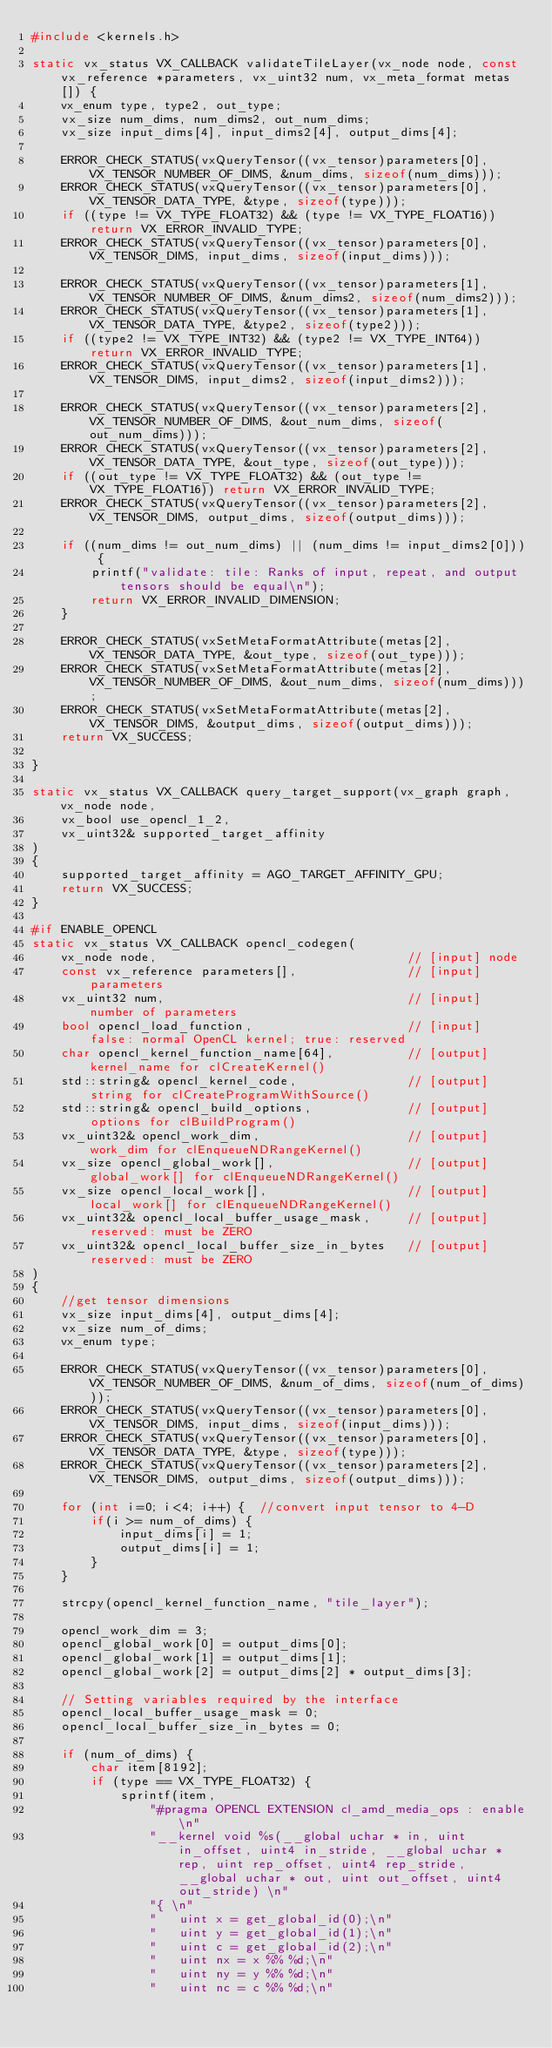Convert code to text. <code><loc_0><loc_0><loc_500><loc_500><_C++_>#include <kernels.h>

static vx_status VX_CALLBACK validateTileLayer(vx_node node, const vx_reference *parameters, vx_uint32 num, vx_meta_format metas[]) {
    vx_enum type, type2, out_type;
    vx_size num_dims, num_dims2, out_num_dims;
    vx_size input_dims[4], input_dims2[4], output_dims[4];
    
    ERROR_CHECK_STATUS(vxQueryTensor((vx_tensor)parameters[0], VX_TENSOR_NUMBER_OF_DIMS, &num_dims, sizeof(num_dims)));
    ERROR_CHECK_STATUS(vxQueryTensor((vx_tensor)parameters[0], VX_TENSOR_DATA_TYPE, &type, sizeof(type)));
    if ((type != VX_TYPE_FLOAT32) && (type != VX_TYPE_FLOAT16)) return VX_ERROR_INVALID_TYPE;
    ERROR_CHECK_STATUS(vxQueryTensor((vx_tensor)parameters[0], VX_TENSOR_DIMS, input_dims, sizeof(input_dims)));

    ERROR_CHECK_STATUS(vxQueryTensor((vx_tensor)parameters[1], VX_TENSOR_NUMBER_OF_DIMS, &num_dims2, sizeof(num_dims2)));
    ERROR_CHECK_STATUS(vxQueryTensor((vx_tensor)parameters[1], VX_TENSOR_DATA_TYPE, &type2, sizeof(type2)));
    if ((type2 != VX_TYPE_INT32) && (type2 != VX_TYPE_INT64)) return VX_ERROR_INVALID_TYPE;
    ERROR_CHECK_STATUS(vxQueryTensor((vx_tensor)parameters[1], VX_TENSOR_DIMS, input_dims2, sizeof(input_dims2)));

    ERROR_CHECK_STATUS(vxQueryTensor((vx_tensor)parameters[2], VX_TENSOR_NUMBER_OF_DIMS, &out_num_dims, sizeof(out_num_dims)));
    ERROR_CHECK_STATUS(vxQueryTensor((vx_tensor)parameters[2], VX_TENSOR_DATA_TYPE, &out_type, sizeof(out_type)));
    if ((out_type != VX_TYPE_FLOAT32) && (out_type != VX_TYPE_FLOAT16)) return VX_ERROR_INVALID_TYPE;
    ERROR_CHECK_STATUS(vxQueryTensor((vx_tensor)parameters[2], VX_TENSOR_DIMS, output_dims, sizeof(output_dims)));

    if ((num_dims != out_num_dims) || (num_dims != input_dims2[0])) {
        printf("validate: tile: Ranks of input, repeat, and output tensors should be equal\n");
        return VX_ERROR_INVALID_DIMENSION;        
    }

    ERROR_CHECK_STATUS(vxSetMetaFormatAttribute(metas[2], VX_TENSOR_DATA_TYPE, &out_type, sizeof(out_type)));
    ERROR_CHECK_STATUS(vxSetMetaFormatAttribute(metas[2], VX_TENSOR_NUMBER_OF_DIMS, &out_num_dims, sizeof(num_dims)));
    ERROR_CHECK_STATUS(vxSetMetaFormatAttribute(metas[2], VX_TENSOR_DIMS, &output_dims, sizeof(output_dims)));
    return VX_SUCCESS;

}

static vx_status VX_CALLBACK query_target_support(vx_graph graph, vx_node node,
    vx_bool use_opencl_1_2,
    vx_uint32& supported_target_affinity
)
{
    supported_target_affinity = AGO_TARGET_AFFINITY_GPU;
    return VX_SUCCESS;
}

#if ENABLE_OPENCL
static vx_status VX_CALLBACK opencl_codegen(
    vx_node node,                                  // [input] node
    const vx_reference parameters[],               // [input] parameters
    vx_uint32 num,                                 // [input] number of parameters
    bool opencl_load_function,                     // [input]  false: normal OpenCL kernel; true: reserved
    char opencl_kernel_function_name[64],          // [output] kernel_name for clCreateKernel()
    std::string& opencl_kernel_code,               // [output] string for clCreateProgramWithSource()
    std::string& opencl_build_options,             // [output] options for clBuildProgram()
    vx_uint32& opencl_work_dim,                    // [output] work_dim for clEnqueueNDRangeKernel()
    vx_size opencl_global_work[],                  // [output] global_work[] for clEnqueueNDRangeKernel()
    vx_size opencl_local_work[],                   // [output] local_work[] for clEnqueueNDRangeKernel()
    vx_uint32& opencl_local_buffer_usage_mask,     // [output] reserved: must be ZERO
    vx_uint32& opencl_local_buffer_size_in_bytes   // [output] reserved: must be ZERO
)
{
    //get tensor dimensions
    vx_size input_dims[4], output_dims[4];
    vx_size num_of_dims;
    vx_enum type;

    ERROR_CHECK_STATUS(vxQueryTensor((vx_tensor)parameters[0], VX_TENSOR_NUMBER_OF_DIMS, &num_of_dims, sizeof(num_of_dims)));
    ERROR_CHECK_STATUS(vxQueryTensor((vx_tensor)parameters[0], VX_TENSOR_DIMS, input_dims, sizeof(input_dims)));
    ERROR_CHECK_STATUS(vxQueryTensor((vx_tensor)parameters[0], VX_TENSOR_DATA_TYPE, &type, sizeof(type)));
    ERROR_CHECK_STATUS(vxQueryTensor((vx_tensor)parameters[2], VX_TENSOR_DIMS, output_dims, sizeof(output_dims)));

    for (int i=0; i<4; i++) {  //convert input tensor to 4-D
        if(i >= num_of_dims) {
            input_dims[i] = 1;
            output_dims[i] = 1;
        }
    }

    strcpy(opencl_kernel_function_name, "tile_layer");

    opencl_work_dim = 3;    
    opencl_global_work[0] = output_dims[0];
    opencl_global_work[1] = output_dims[1];
    opencl_global_work[2] = output_dims[2] * output_dims[3];

    // Setting variables required by the interface
    opencl_local_buffer_usage_mask = 0;
    opencl_local_buffer_size_in_bytes = 0;

    if (num_of_dims) {
        char item[8192];
        if (type == VX_TYPE_FLOAT32) {
            sprintf(item,
                "#pragma OPENCL EXTENSION cl_amd_media_ops : enable\n"
                "__kernel void %s(__global uchar * in, uint in_offset, uint4 in_stride, __global uchar * rep, uint rep_offset, uint4 rep_stride, __global uchar * out, uint out_offset, uint4 out_stride) \n"
                "{ \n"
                "   uint x = get_global_id(0);\n"
                "   uint y = get_global_id(1);\n"
                "   uint c = get_global_id(2);\n"
                "   uint nx = x %% %d;\n"
                "   uint ny = y %% %d;\n"
                "   uint nc = c %% %d;\n"</code> 